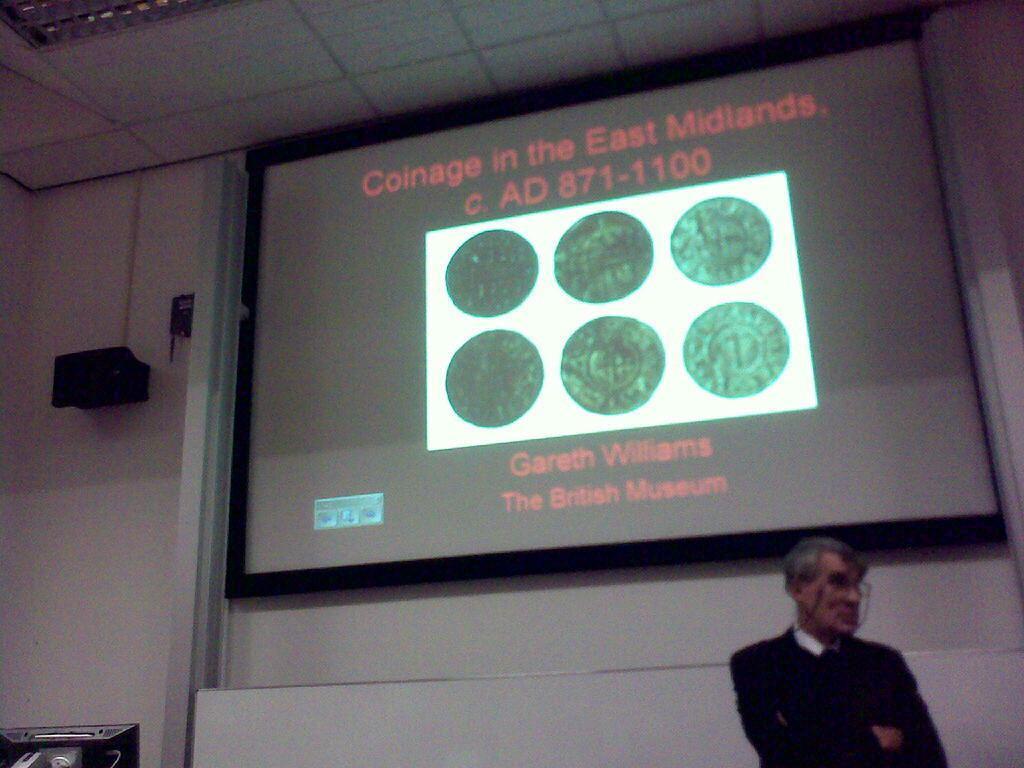How would you summarize this image in a sentence or two? In this image we can see a person standing and in the background, we can see a screen with some text and pictures and there is a speaker attached to the wall. We can see a monitor on the left side of the image. 